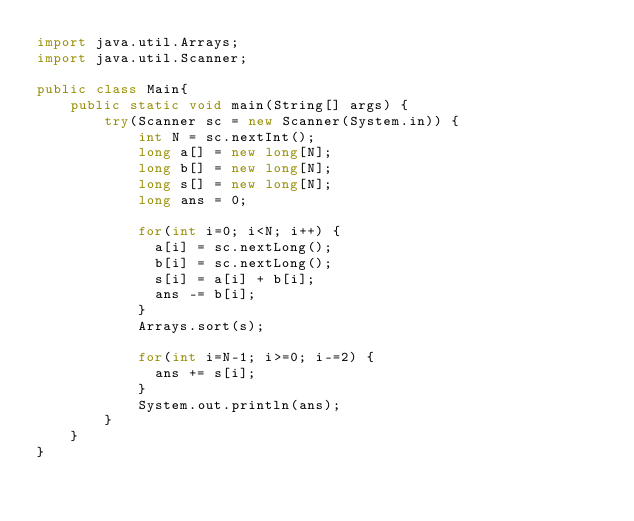<code> <loc_0><loc_0><loc_500><loc_500><_Java_>import java.util.Arrays;
import java.util.Scanner;
 
public class Main{
    public static void main(String[] args) {
        try(Scanner sc = new Scanner(System.in)) {
            int N = sc.nextInt();
            long a[] = new long[N];
            long b[] = new long[N];
            long s[] = new long[N];
            long ans = 0;
            
            for(int i=0; i<N; i++) {
            	a[i] = sc.nextLong();
            	b[i] = sc.nextLong();
            	s[i] = a[i] + b[i];
            	ans -= b[i];
            }
            Arrays.sort(s);
            
            for(int i=N-1; i>=0; i-=2) {
            	ans += s[i];
            }
            System.out.println(ans);
        }
    }
}</code> 